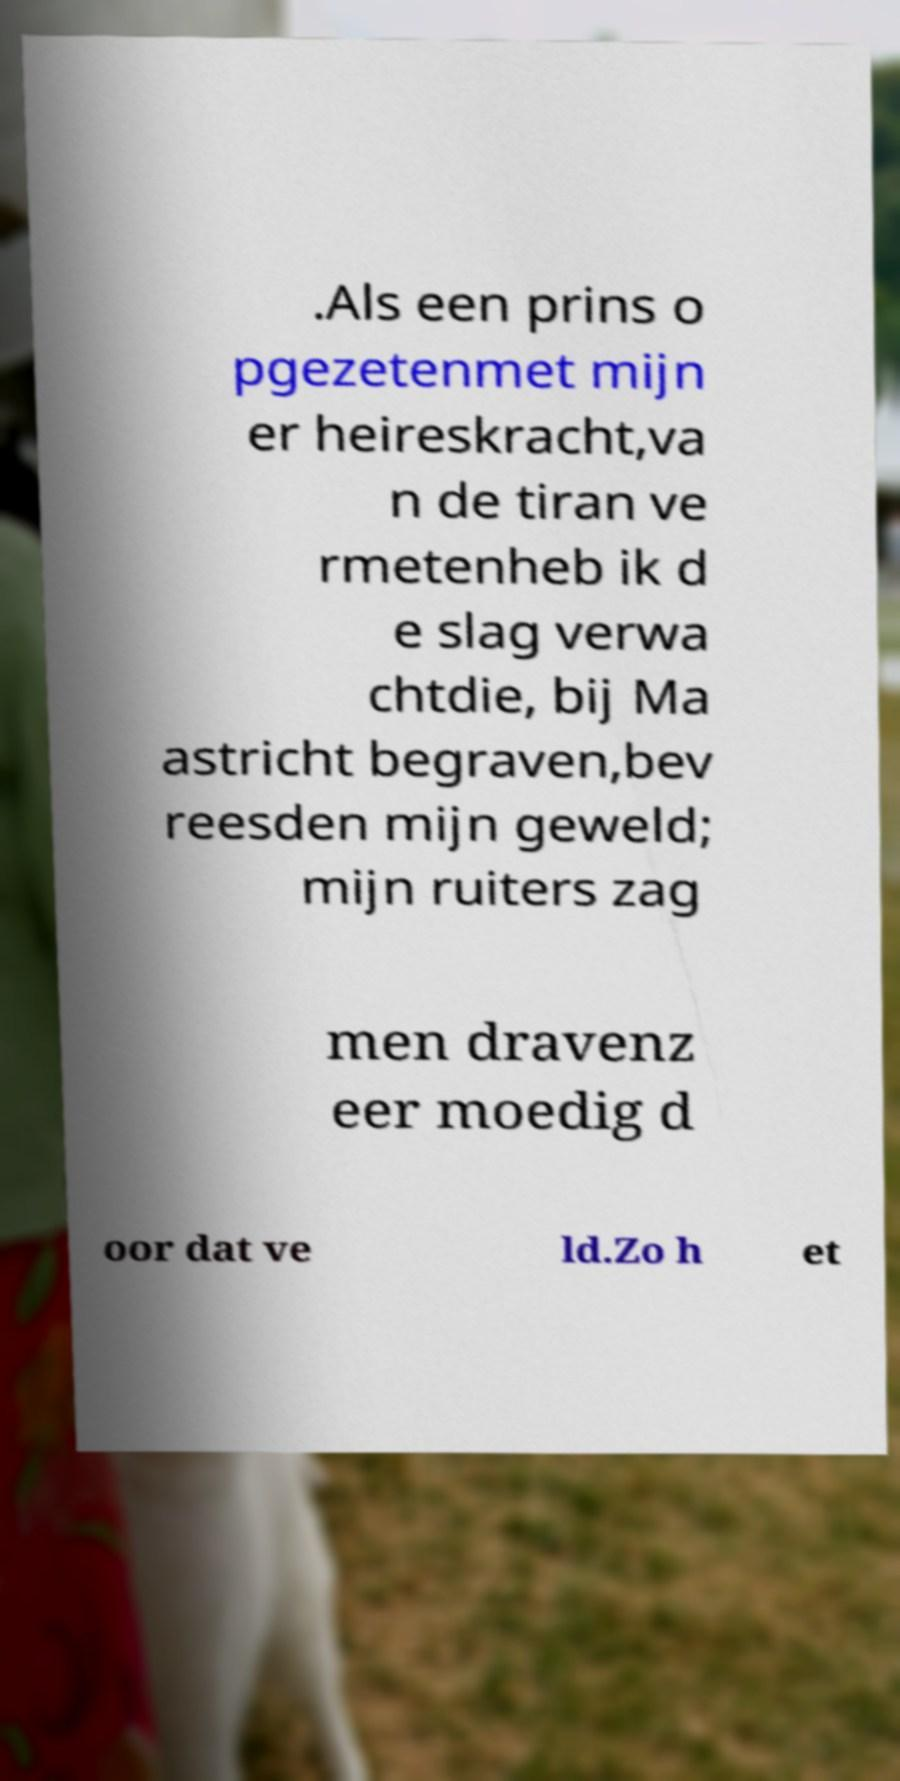For documentation purposes, I need the text within this image transcribed. Could you provide that? .Als een prins o pgezetenmet mijn er heireskracht,va n de tiran ve rmetenheb ik d e slag verwa chtdie, bij Ma astricht begraven,bev reesden mijn geweld; mijn ruiters zag men dravenz eer moedig d oor dat ve ld.Zo h et 